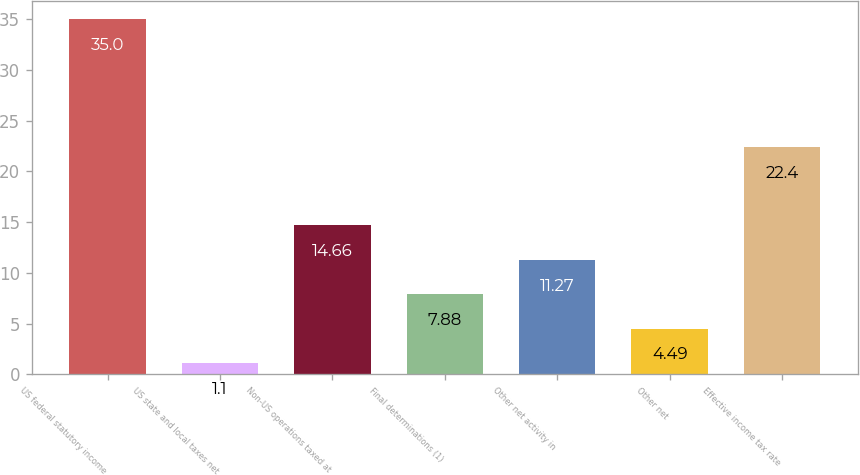<chart> <loc_0><loc_0><loc_500><loc_500><bar_chart><fcel>US federal statutory income<fcel>US state and local taxes net<fcel>Non-US operations taxed at<fcel>Final determinations (1)<fcel>Other net activity in<fcel>Other net<fcel>Effective income tax rate<nl><fcel>35<fcel>1.1<fcel>14.66<fcel>7.88<fcel>11.27<fcel>4.49<fcel>22.4<nl></chart> 